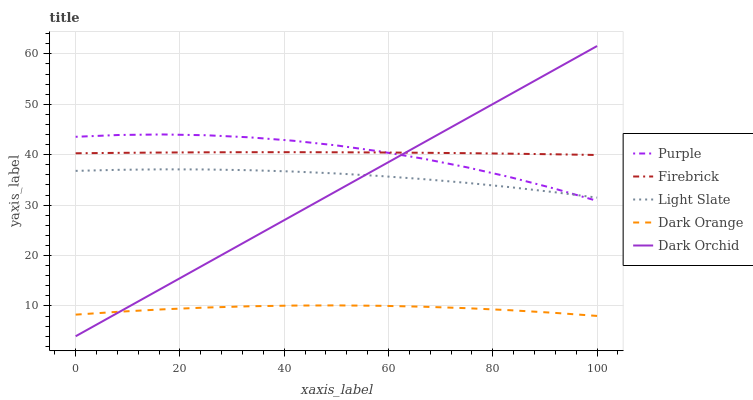Does Dark Orange have the minimum area under the curve?
Answer yes or no. Yes. Does Firebrick have the maximum area under the curve?
Answer yes or no. Yes. Does Light Slate have the minimum area under the curve?
Answer yes or no. No. Does Light Slate have the maximum area under the curve?
Answer yes or no. No. Is Dark Orchid the smoothest?
Answer yes or no. Yes. Is Purple the roughest?
Answer yes or no. Yes. Is Light Slate the smoothest?
Answer yes or no. No. Is Light Slate the roughest?
Answer yes or no. No. Does Dark Orchid have the lowest value?
Answer yes or no. Yes. Does Light Slate have the lowest value?
Answer yes or no. No. Does Dark Orchid have the highest value?
Answer yes or no. Yes. Does Light Slate have the highest value?
Answer yes or no. No. Is Light Slate less than Firebrick?
Answer yes or no. Yes. Is Purple greater than Dark Orange?
Answer yes or no. Yes. Does Purple intersect Firebrick?
Answer yes or no. Yes. Is Purple less than Firebrick?
Answer yes or no. No. Is Purple greater than Firebrick?
Answer yes or no. No. Does Light Slate intersect Firebrick?
Answer yes or no. No. 